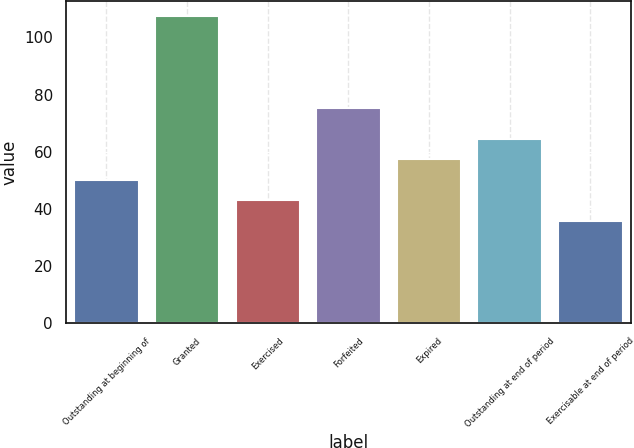Convert chart to OTSL. <chart><loc_0><loc_0><loc_500><loc_500><bar_chart><fcel>Outstanding at beginning of<fcel>Granted<fcel>Exercised<fcel>Forfeited<fcel>Expired<fcel>Outstanding at end of period<fcel>Exercisable at end of period<nl><fcel>50.18<fcel>107.31<fcel>43.04<fcel>75.26<fcel>57.32<fcel>64.46<fcel>35.9<nl></chart> 